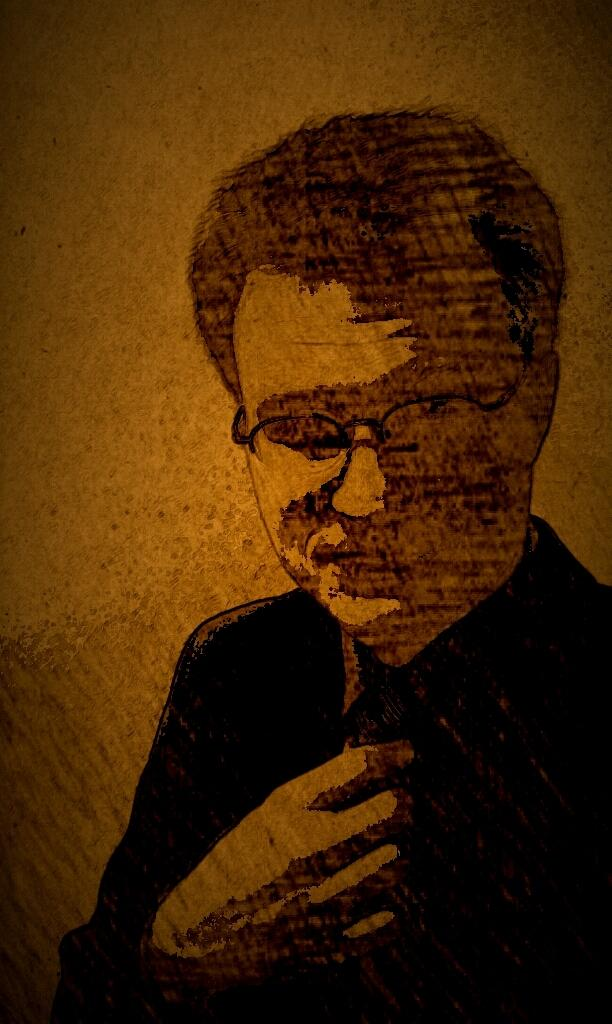What is depicted in the image? There is a sketch of a person in the image. What can be observed about the background of the image? The background color is brown. What is the sister doing in the image? There is no mention of a sister in the image or the provided facts. 